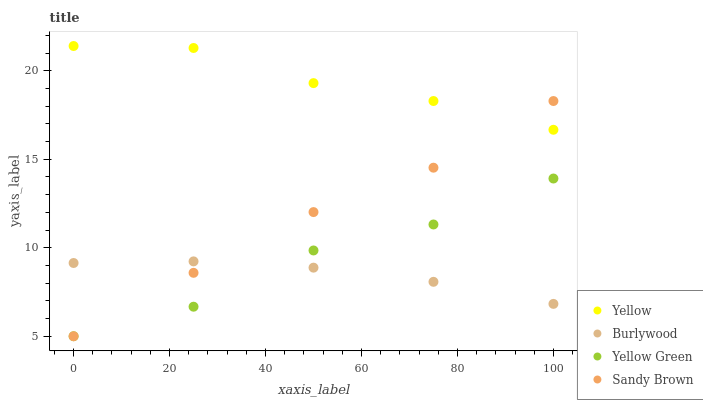Does Burlywood have the minimum area under the curve?
Answer yes or no. Yes. Does Yellow have the maximum area under the curve?
Answer yes or no. Yes. Does Sandy Brown have the minimum area under the curve?
Answer yes or no. No. Does Sandy Brown have the maximum area under the curve?
Answer yes or no. No. Is Burlywood the smoothest?
Answer yes or no. Yes. Is Yellow Green the roughest?
Answer yes or no. Yes. Is Sandy Brown the smoothest?
Answer yes or no. No. Is Sandy Brown the roughest?
Answer yes or no. No. Does Sandy Brown have the lowest value?
Answer yes or no. Yes. Does Yellow have the lowest value?
Answer yes or no. No. Does Yellow have the highest value?
Answer yes or no. Yes. Does Sandy Brown have the highest value?
Answer yes or no. No. Is Burlywood less than Yellow?
Answer yes or no. Yes. Is Yellow greater than Burlywood?
Answer yes or no. Yes. Does Yellow intersect Sandy Brown?
Answer yes or no. Yes. Is Yellow less than Sandy Brown?
Answer yes or no. No. Is Yellow greater than Sandy Brown?
Answer yes or no. No. Does Burlywood intersect Yellow?
Answer yes or no. No. 